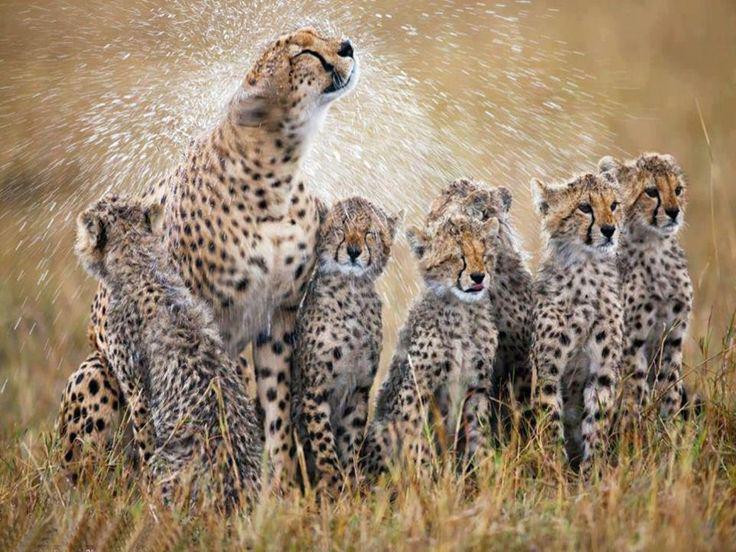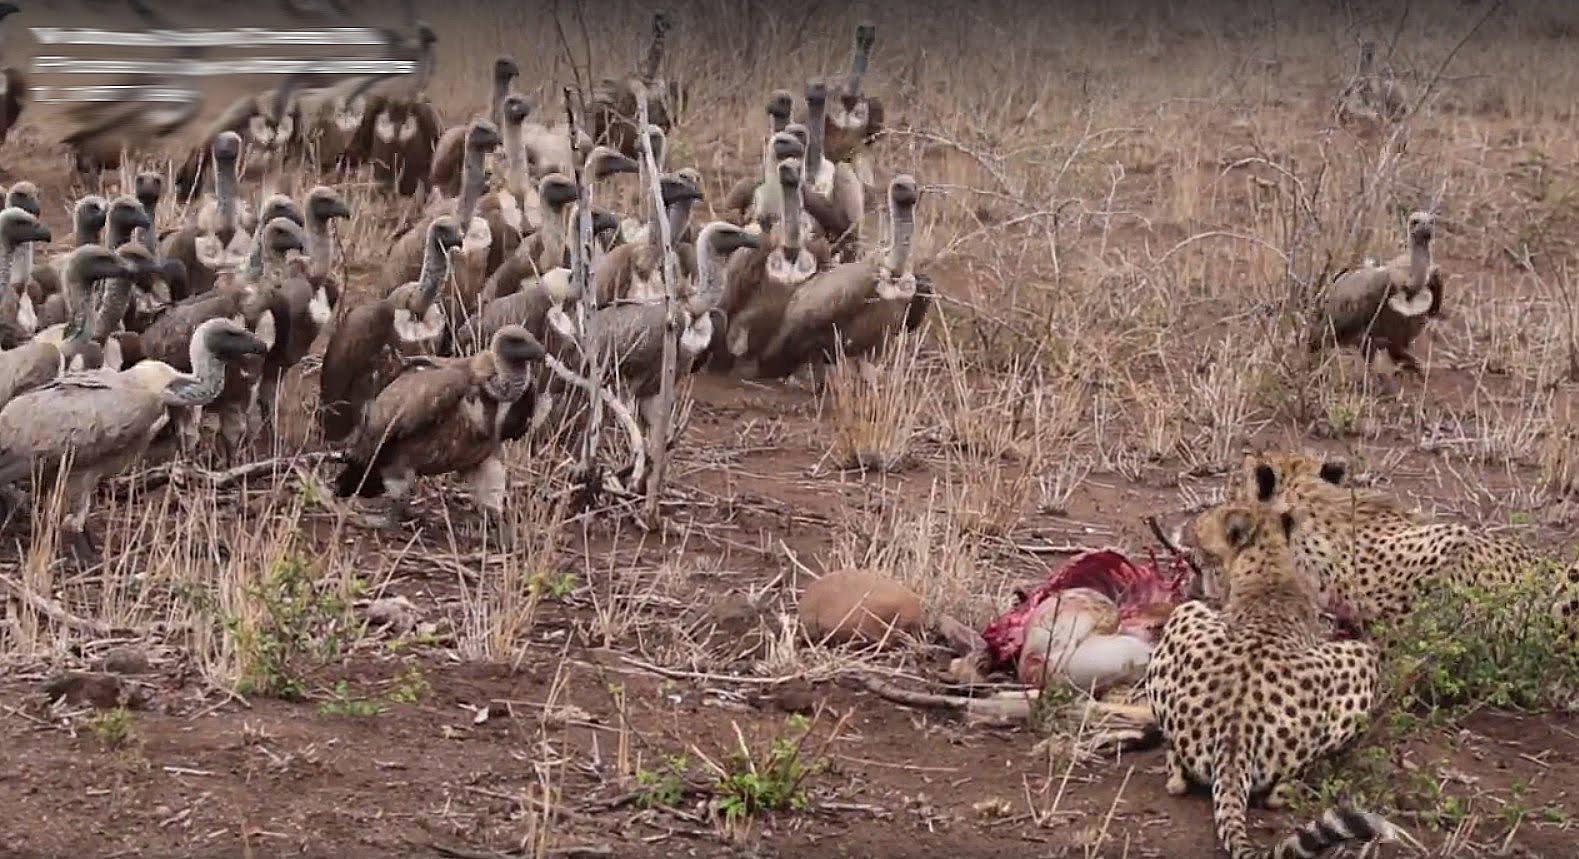The first image is the image on the left, the second image is the image on the right. Assess this claim about the two images: "At least one vulture is in the air.". Correct or not? Answer yes or no. No. The first image is the image on the left, the second image is the image on the right. Assess this claim about the two images: "There are two cheetahs eat pry as a wall of at least 10 vulture wait to get the leftovers.". Correct or not? Answer yes or no. Yes. 